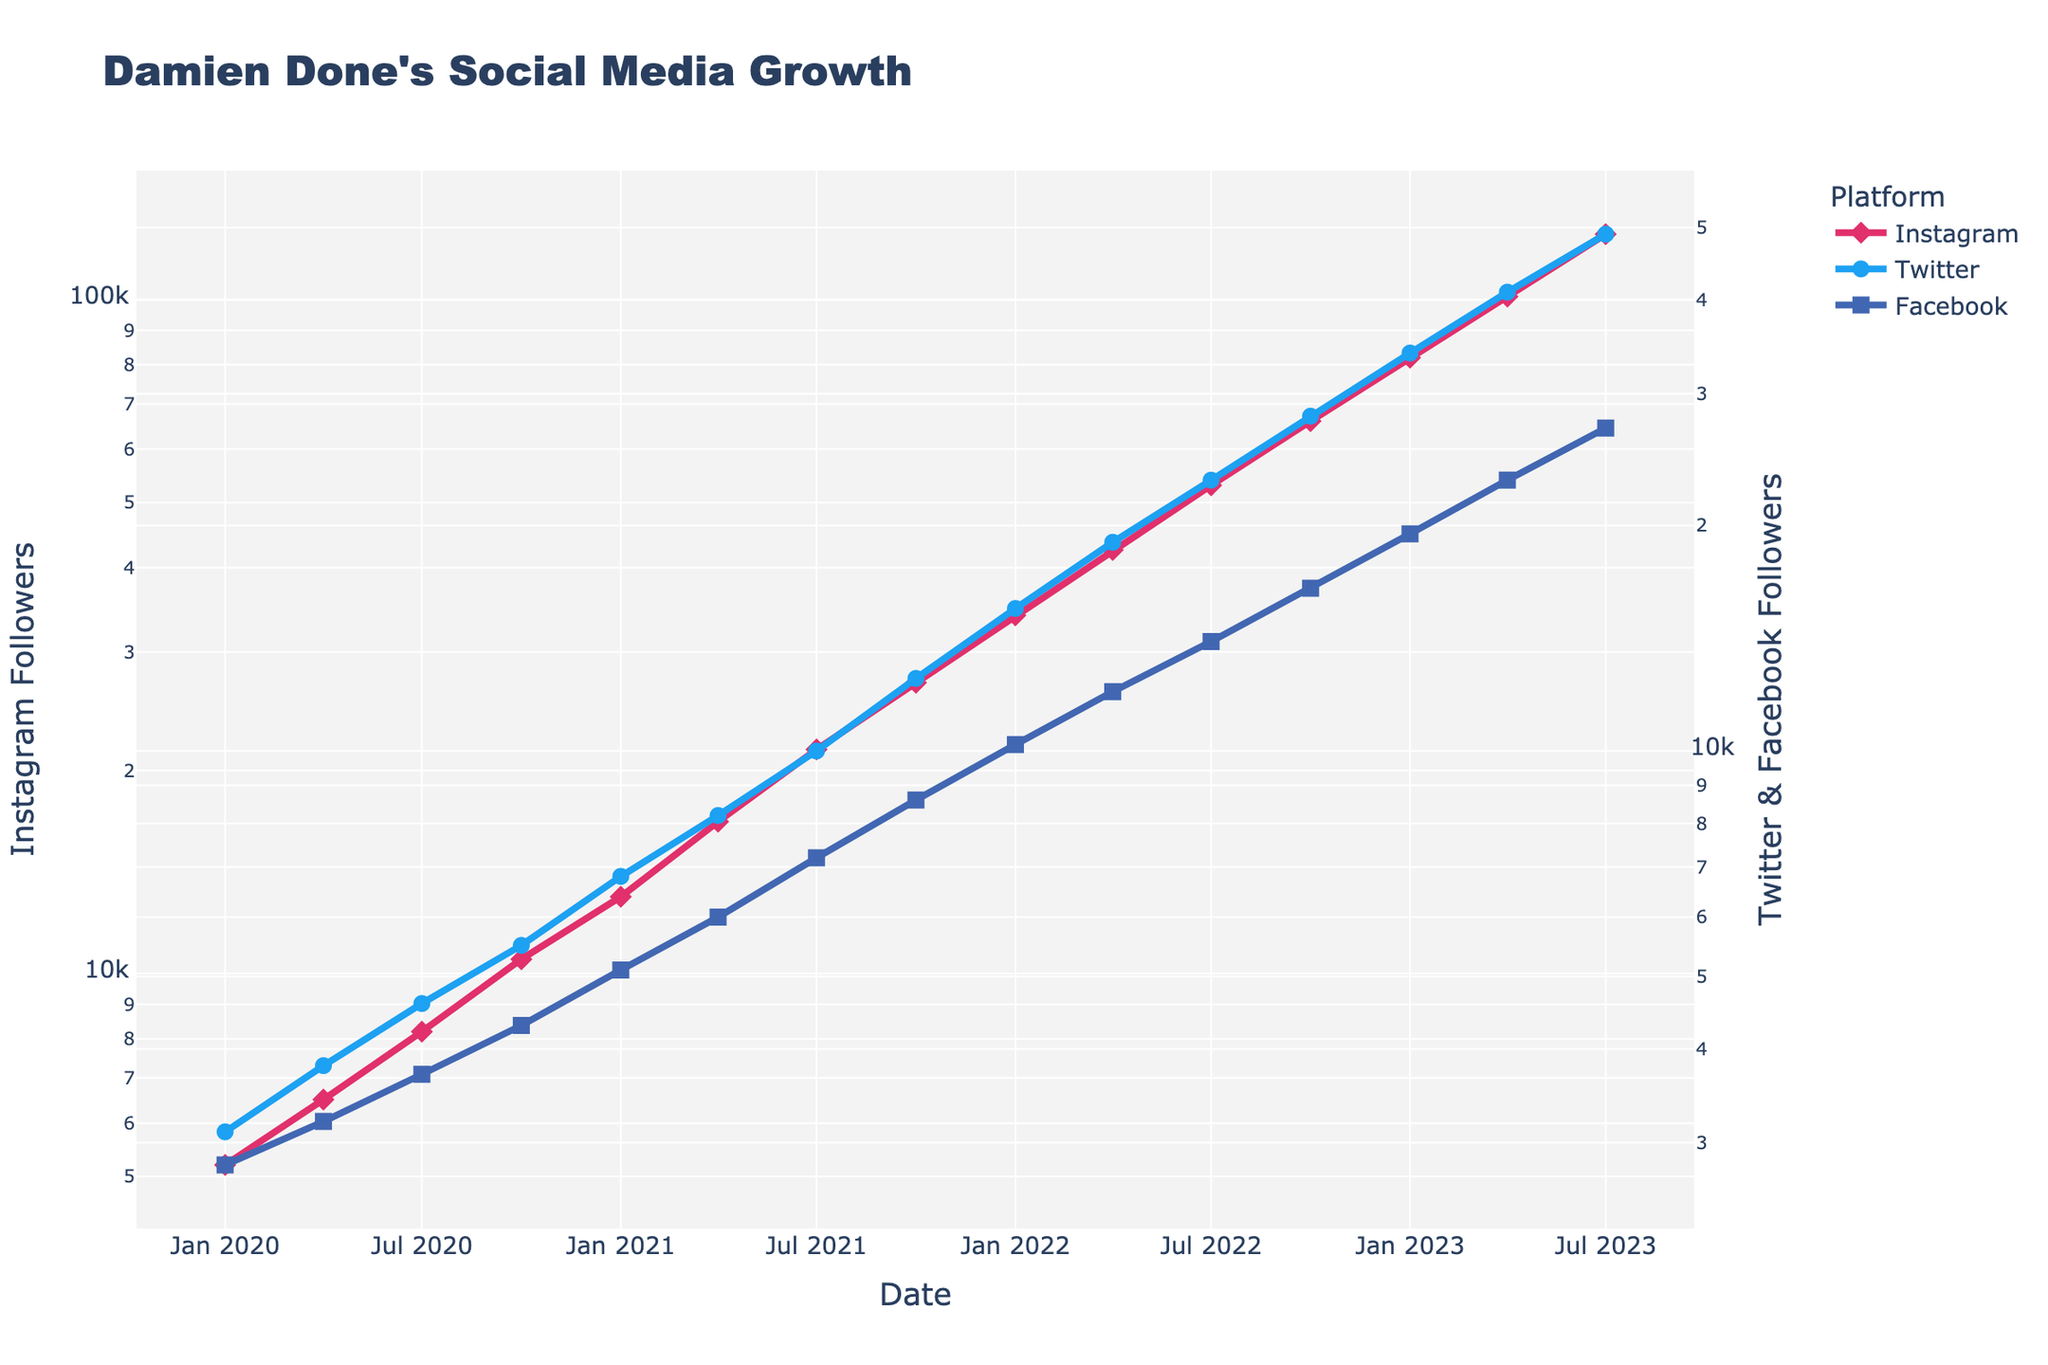What is the total number of Instagram followers by April 2023? To determine the total number of Instagram followers in April 2023, look at the Instagram axis under the date "2023-04-01". The value is 101,000 followers.
Answer: 101,000 Which platform had the lowest follower count at the start of 2021? Compare the follower counts for Instagram, Twitter, and Facebook at the start of 2021 (January 2021). Instagram has 13,000 followers, Twitter has 6,800 followers, and Facebook has 5,100 followers, with Facebook having the lowest.
Answer: Facebook By how much did Damien Done's Instagram followers increase from July 2022 to January 2023? Look at the Instagram follower counts for July 2022 (53,000) and January 2023 (82,000). The increase is 82,000 - 53,000, which equals 29,000 followers.
Answer: 29,000 What is the overall trend in the follower count for Facebook? Observing the Facebook follower count from January 2020 to July 2023, it consistently increases from 2,800 to 27,000.
Answer: Increasing Which platform shows the fastest growth rate from January 2023 to July 2023? Examine the growth in followers for each platform between January 2023 and July 2023. Instagram grows from 82,000 to 125,000 (43,000), Twitter from 34,000 to 49,000 (15,000), and Facebook from 19,500 to 27,000 (7,500). The largest increase is on Instagram.
Answer: Instagram During which period did Twitter experience the steepest increase in followers? Investigate the follower count increases in each period. The steepest increase for Twitter is visible between October 2022 and January 2023, growing from 28,000 to 34,000 (6,000).
Answer: October 2022 to January 2023 What was the follower count difference between Instagram and Twitter in July 2021? For July 2021, Instagram had 21,500 followers and Twitter had 10,000. The difference is 21,500 - 10,000, which equals 11,500 followers.
Answer: 11,500 How many more followers did Damien Done have on Instagram compared to Facebook at the end of 2022? At the end of 2022 (December), Instagram had 66,000 followers, and Facebook had 16,500. The difference is 66,000 - 16,500, which equals 49,500 followers.
Answer: 49,500 What color represents the Instagram follower count on the plot? Refer to the visual attributes of the plot. The Instagram line is represented in pink.
Answer: Pink 